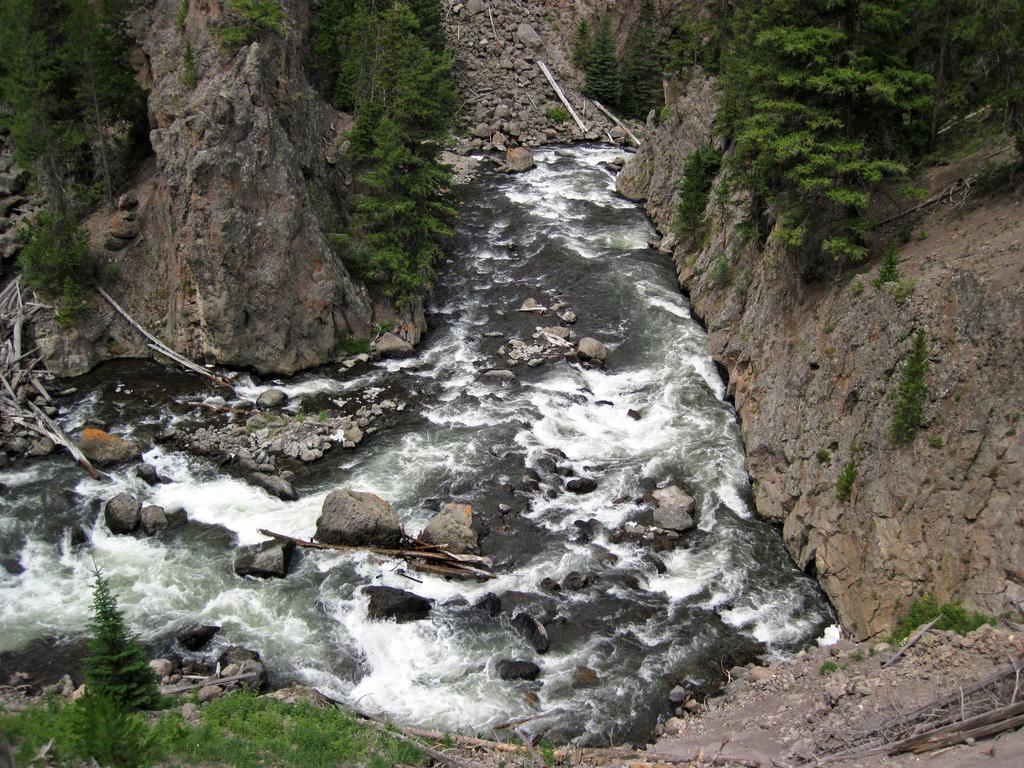What type of natural feature is depicted in the image? There is a river in the image. What can be seen in the center of the image? There are many stones in the center of the image. What type of vegetation is visible at the top of the image? There are trees visible at the top of the image. What type of ground cover is present at the bottom of the image? Green grass is present at the bottom of the image. How many babies are playing in the river in the image? There are no babies present in the image; it features a river with stones and trees. What type of mountain range can be seen in the background of the image? There is no mountain range visible in the image; it features a river, stones, trees, and grass. 